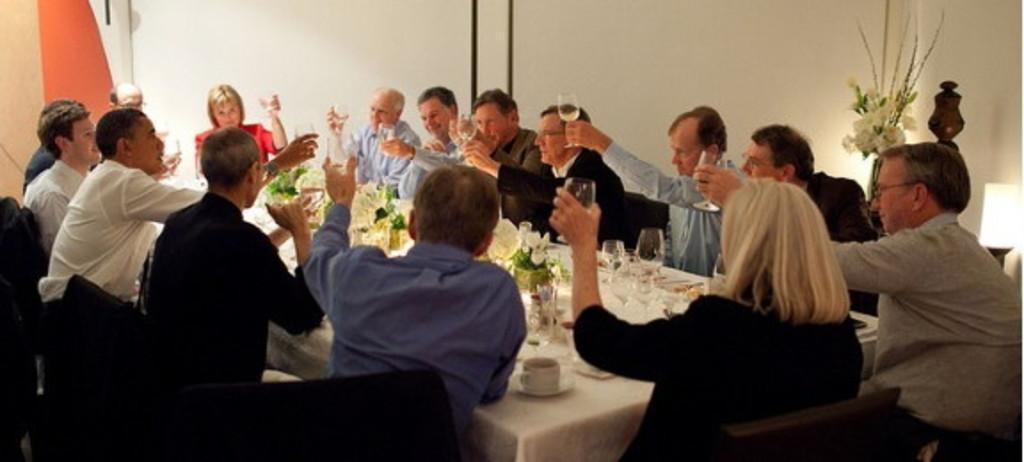How would you summarize this image in a sentence or two? This is a picture taken in a room, there are a group of people sitting on a chair holding glasses in front of the people there is a table covered with cloth on the table there is a glasses, flower pot, cup and saucer. Background of this people is a wall and flower pot. 